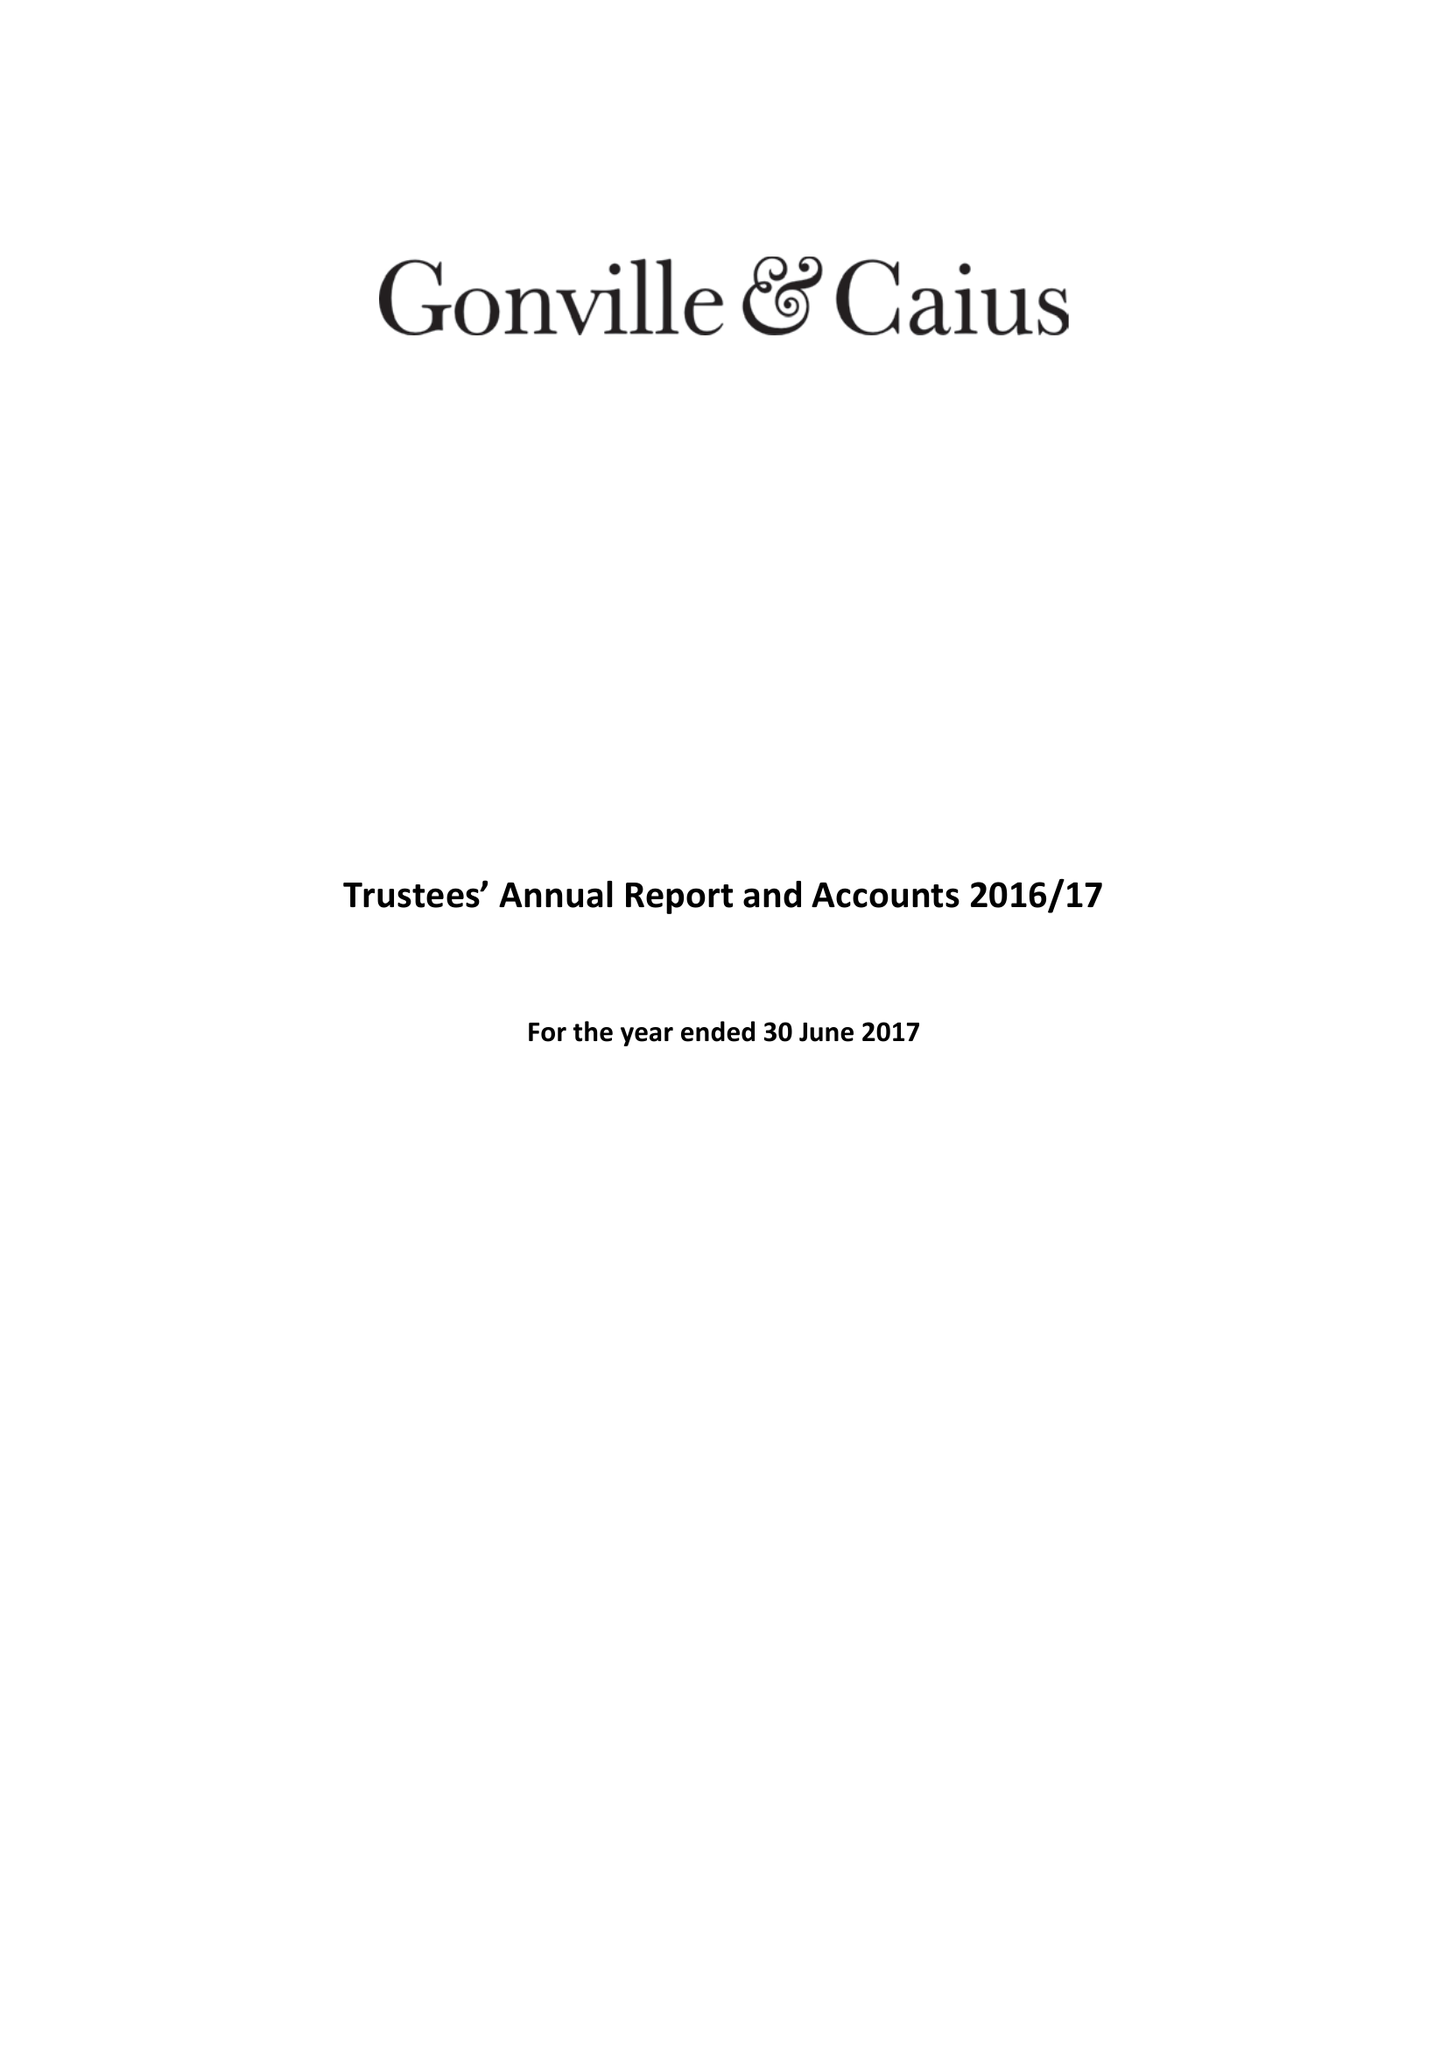What is the value for the report_date?
Answer the question using a single word or phrase. 2017-06-30 